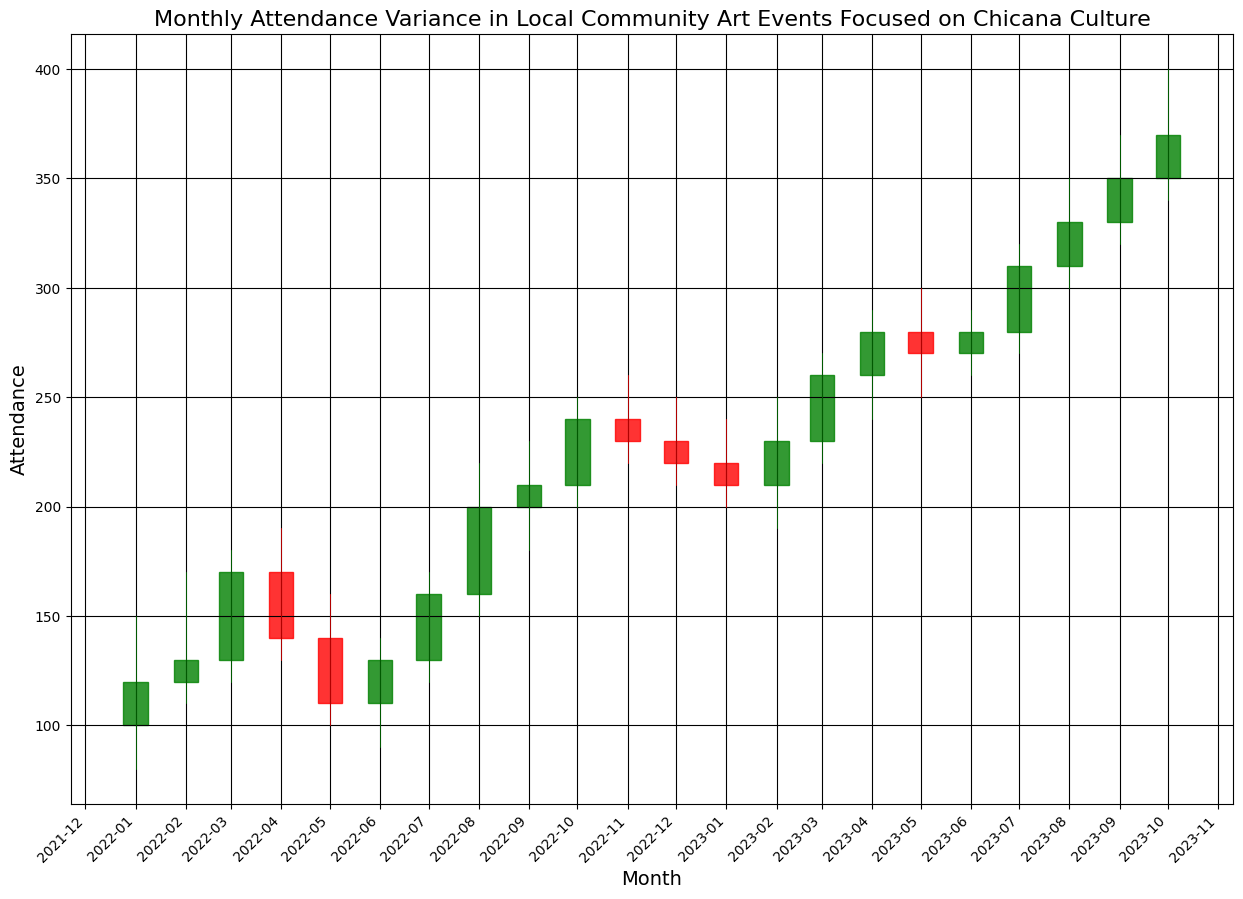What was the highest attendance recorded between January and June 2022? The highest attendance recorded between January and June 2022 is found by looking at the 'High' values for each respective month. For these months, the 'High' values are 150, 170, 180, 190, 160, and 140. The highest value among these is 190, recorded in April 2022.
Answer: 190 Which month had the lowest closing attendance in 2022? To find the month with the lowest closing attendance in 2022, we need to compare the 'Close' values from January to December 2022. The closing values are 120, 130, 170, 140, 110, 130, 160, 200, 210, 240, 230, and 220. The lowest closing value among these is 110, recorded in May 2022.
Answer: May 2022 How does the closing attendance in July 2022 compare to July 2023? To compare the closing attendance between July 2022 and July 2023, we observe the 'Close' values for these months. The closing value for July 2022 is 160, while for July 2023, it is 310. The attendance in July 2023 is 150 more than in July 2022.
Answer: 310 is greater than 160 by 150 Which month saw the greatest increase in attendance from the previous month in 2023? To find the greatest increase in attendance from the previous month in 2023, we calculate the difference in 'Close' values month-to-month. The greatest increase in closing attendance occurred between March 2023 (260) and April 2023 (280), with an increase of 20.
Answer: April 2023 What is the average high attendance for the first quarter of 2023? To calculate the average high attendance for the first quarter of 2023 (January, February, and March), we sum the 'High' values for these months, which are 240, 250, and 270, and then divide by 3. The sum is 240 + 250 + 270 = 760, and the average is 760 / 3 = 253.33.
Answer: 253.33 Considering 2022, in how many months was the closing attendance higher than the opening attendance? To determine the number of months in 2022 where the closing attendance was higher than the opening attendance, we compare the 'Open' and 'Close' values for each month. The closing attendance is higher than the opening attendance in January (120 > 100), February (130 > 120), March (170 > 130), July (160 > 130), August (200 > 160), September (210 > 200), October (240 > 210), and November (230 > 240). This happens in 8 months.
Answer: 8 months What was the trend in the closing attendance from August 2023 to October 2023? To determine the trend in the closing attendance from August 2023 to October 2023, we look at the 'Close' values for these months, which are 330 in August, 350 in September, and 370 in October. The closing attendance is increasing each month.
Answer: Increasing During which month in 2022-2023 did the attendance spike to the highest recorded value? To find out when the attendance spiked to the highest recorded value, we check the 'High' values across all months from 2022 to 2023. The highest value, 400, is recorded in October 2023.
Answer: October 2023 What is the lowest low attendance over the entire dataset? To find the lowest low attendance over the entire dataset, we check the 'Low' values of each month. The lowest value, 80, occurred in January 2022.
Answer: 80 